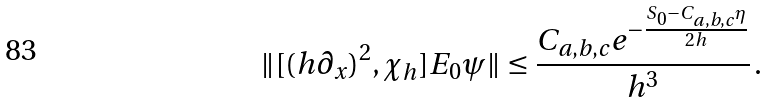Convert formula to latex. <formula><loc_0><loc_0><loc_500><loc_500>\| [ ( h \partial _ { x } ) ^ { 2 } , \chi _ { h } ] E _ { 0 } \psi \| \leq \frac { C _ { a , b , c } e ^ { - \frac { S _ { 0 } - C _ { a , b , c } \eta } { 2 h } } } { h ^ { 3 } } \, .</formula> 